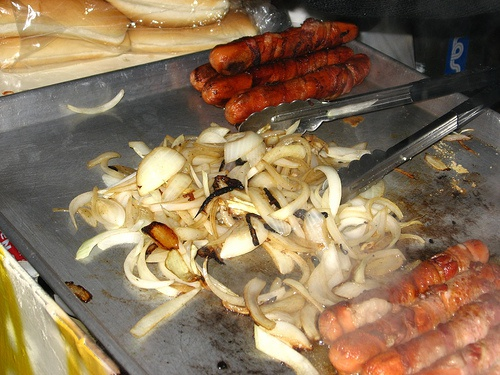Describe the objects in this image and their specific colors. I can see hot dog in maroon, brown, and salmon tones, hot dog in maroon, brown, and tan tones, hot dog in maroon, black, and brown tones, hot dog in maroon, black, and brown tones, and hot dog in maroon, salmon, tan, and brown tones in this image. 